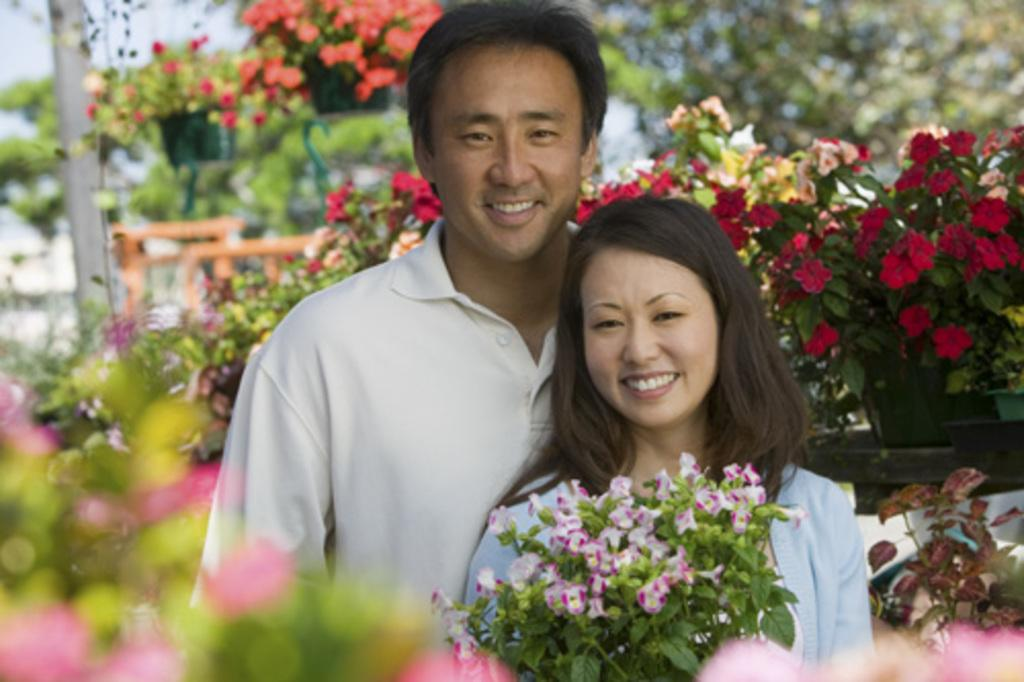Who is present in the image? There is a man and a woman in the image. What are the expressions of the people in the image? Both the man and the woman are smiling. What can be seen in the background of the image? There are flower pots and the sky visible in the background of the image. What type of wound can be seen on the woman's arm in the image? There is no wound visible on the woman's arm in the image. What kind of shop is located near the flower pots in the image? There is no shop mentioned or visible in the image; it only features a man, a woman, and flower pots in the background. 